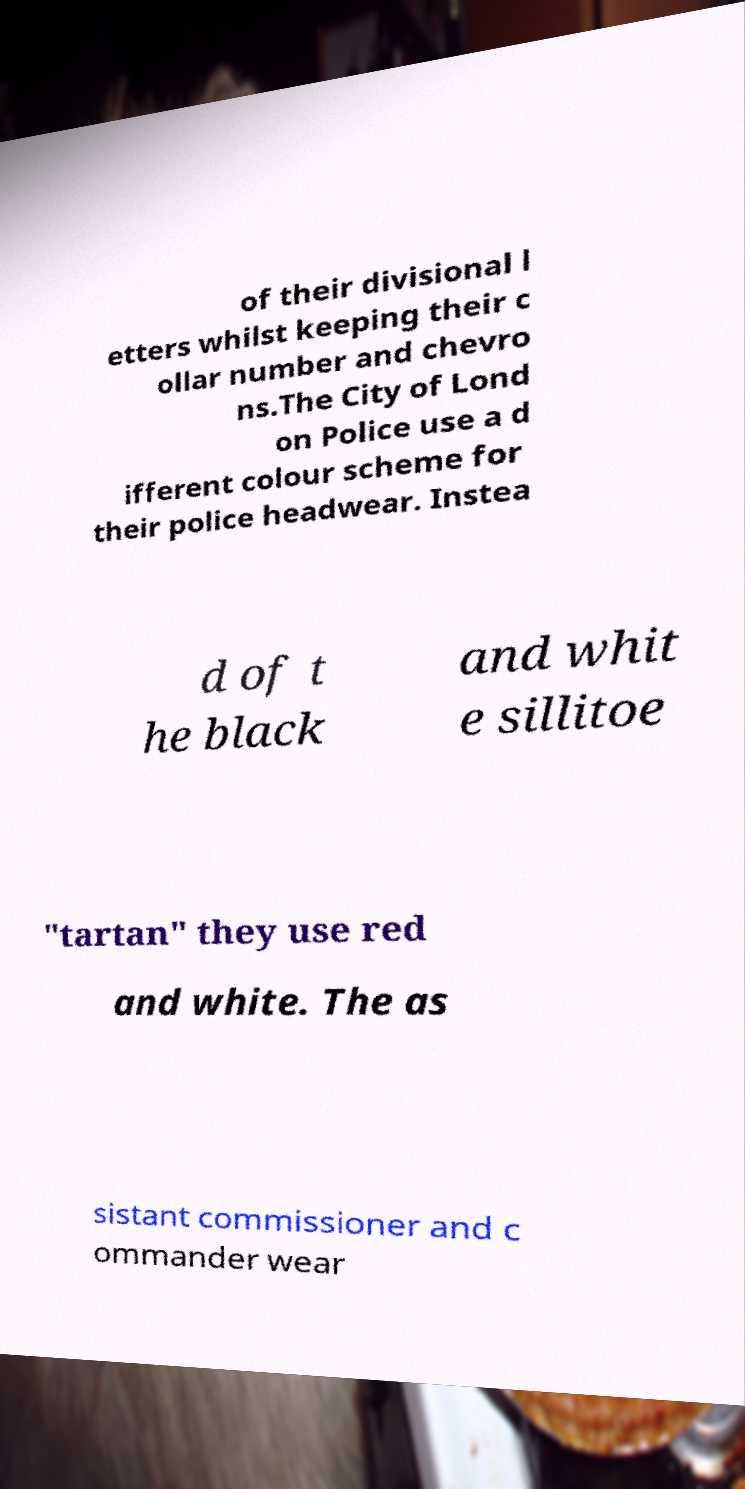I need the written content from this picture converted into text. Can you do that? of their divisional l etters whilst keeping their c ollar number and chevro ns.The City of Lond on Police use a d ifferent colour scheme for their police headwear. Instea d of t he black and whit e sillitoe "tartan" they use red and white. The as sistant commissioner and c ommander wear 